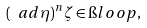<formula> <loc_0><loc_0><loc_500><loc_500>( \ a d \eta ) ^ { n } \zeta \in \i l o o p ,</formula> 